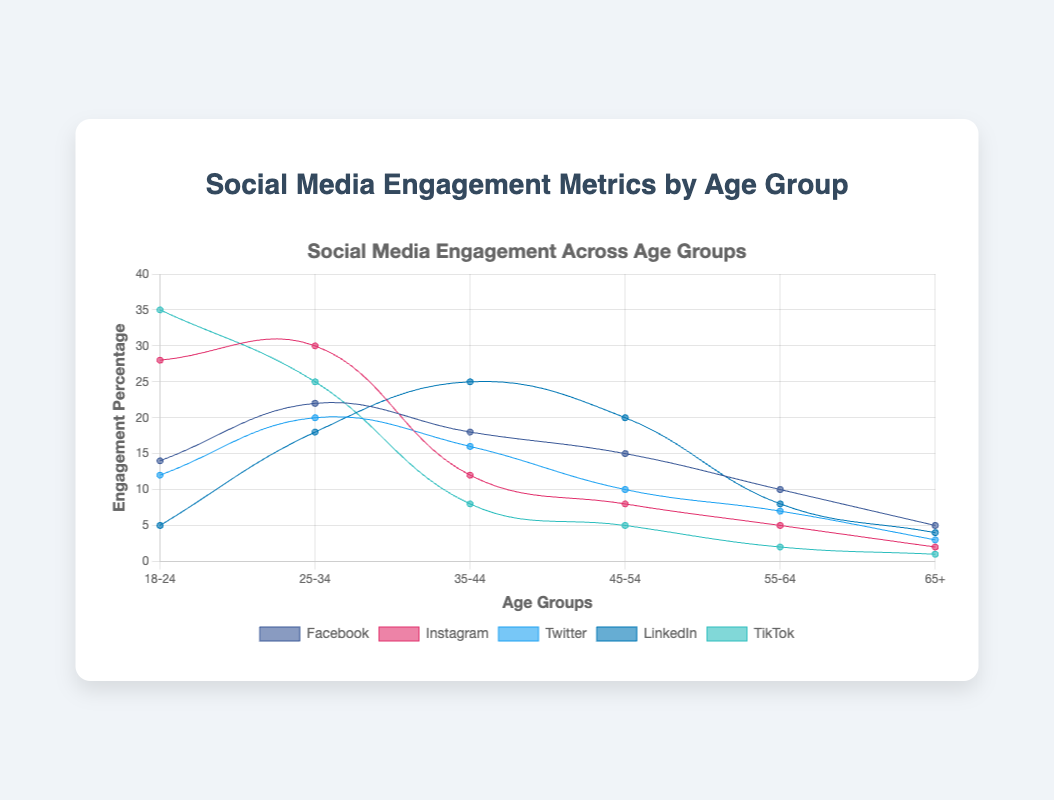What's the highest engagement percentage for TikTok among the age groups? The highest engagement percentage for TikTok is shown where it reaches its peak value in the data points. From the figure, TikTok has its highest engagement with the "18-24" age group at 35%.
Answer: 35% Which age group has the highest engagement on Facebook? To find the highest engagement, look at the peaks of the Facebook dataset. The "25-34" age group shows the peak value which is 22%.
Answer: 25-34 How does the engagement of Instagram for the "18-24" age group compare to TikTok for the same age group? Look at the data points for the "18-24" age group for both Instagram and TikTok. Instagram has 28%, whereas TikTok has 35%. TikTok's engagement is higher by 7%.
Answer: TikTok's engagement is higher by 7% What’s the total engagement percentage of LinkedIn for all age groups combined? To find the total, sum the values of LinkedIn across all age groups: 5 (18-24) + 18 (25-34) + 25 (35-44) + 20 (45-54) + 8 (55-64) + 4 (65+). This equals 80%.
Answer: 80% Which social media platform has the least engagement with the "55-64" age group? Check the data points for the "55-64" age group. The platform with the smallest value is TikTok at 2%.
Answer: TikTok What is the average engagement percentage for Twitter across age groups? Sum all the Twitter values and divide by the number of age groups: (12 + 20 + 16 + 10 + 7 + 3) / 6 = 68 / 6 = 11.33%.
Answer: 11.33% Compare the engagement percentages of the "35-44" age group on LinkedIn and Instagram, and state which one is higher. Look at the data points for the "35-44" age group. LinkedIn has 25%, while Instagram has 12%. LinkedIn has a higher engagement percentage.
Answer: LinkedIn Which two age groups have the closest engagement percentages on Twitter? Look at the Twitter data points and compare the values: "18-24" (12) and "45-54" (10) are only 2 percentage points apart.
Answer: 18-24 and 45-54 How does the engagement trend for Facebook differ between the "18-24" and "65+" age groups? Observe the Facebook data points: it starts higher at 14% for "18-24" and decreases down to 5% for "65+". Engagement declines as age increases.
Answer: Declines as age increases 